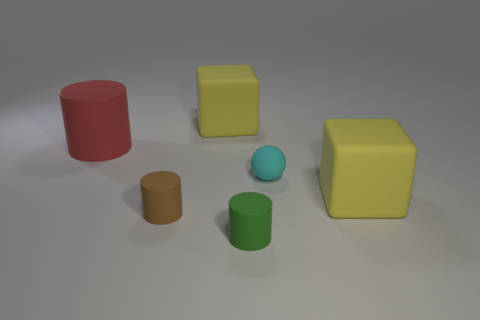Subtract all green balls. Subtract all blue cubes. How many balls are left? 1 Add 4 rubber cubes. How many objects exist? 10 Subtract all blocks. How many objects are left? 4 Add 5 small brown metal spheres. How many small brown metal spheres exist? 5 Subtract 0 gray cylinders. How many objects are left? 6 Subtract all large green blocks. Subtract all green cylinders. How many objects are left? 5 Add 3 cylinders. How many cylinders are left? 6 